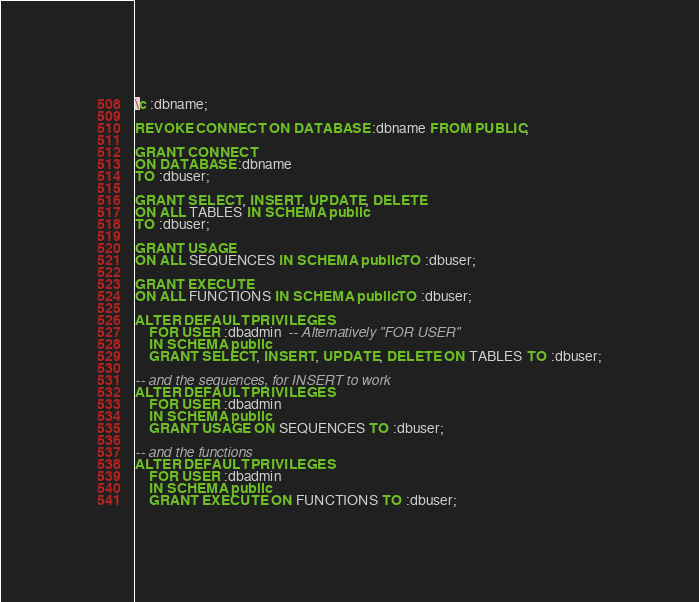<code> <loc_0><loc_0><loc_500><loc_500><_SQL_>\c :dbname;

REVOKE CONNECT ON DATABASE :dbname FROM PUBLIC;

GRANT CONNECT
ON DATABASE :dbname
TO :dbuser;

GRANT SELECT, INSERT, UPDATE, DELETE
ON ALL TABLES IN SCHEMA public 
TO :dbuser;

GRANT USAGE
ON ALL SEQUENCES IN SCHEMA public TO :dbuser;

GRANT EXECUTE
ON ALL FUNCTIONS IN SCHEMA public TO :dbuser;

ALTER DEFAULT PRIVILEGES 
    FOR USER :dbadmin  -- Alternatively "FOR USER"
    IN SCHEMA public
    GRANT SELECT, INSERT, UPDATE, DELETE ON TABLES TO :dbuser;

-- and the sequences, for INSERT to work
ALTER DEFAULT PRIVILEGES
    FOR USER :dbadmin
    IN SCHEMA public
    GRANT USAGE ON SEQUENCES TO :dbuser;
    
-- and the functions
ALTER DEFAULT PRIVILEGES
    FOR USER :dbadmin
    IN SCHEMA public
    GRANT EXECUTE ON FUNCTIONS TO :dbuser;
</code> 